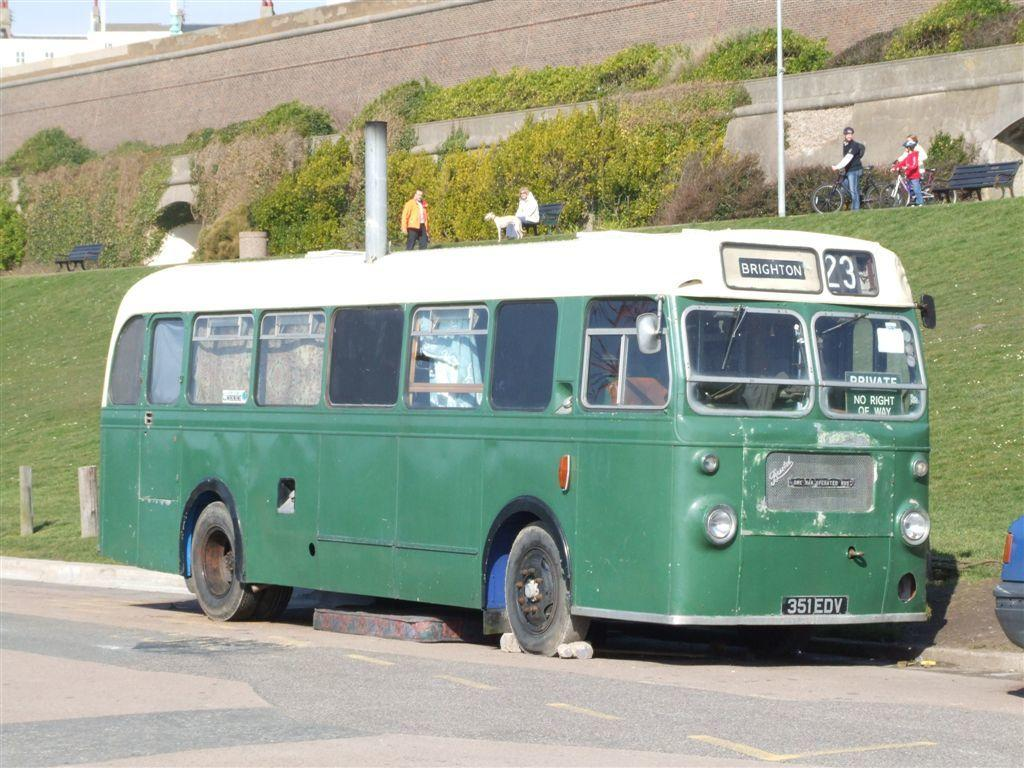<image>
Present a compact description of the photo's key features. A green bus with a white roof is on the number 23 route, heading to Brighton. 